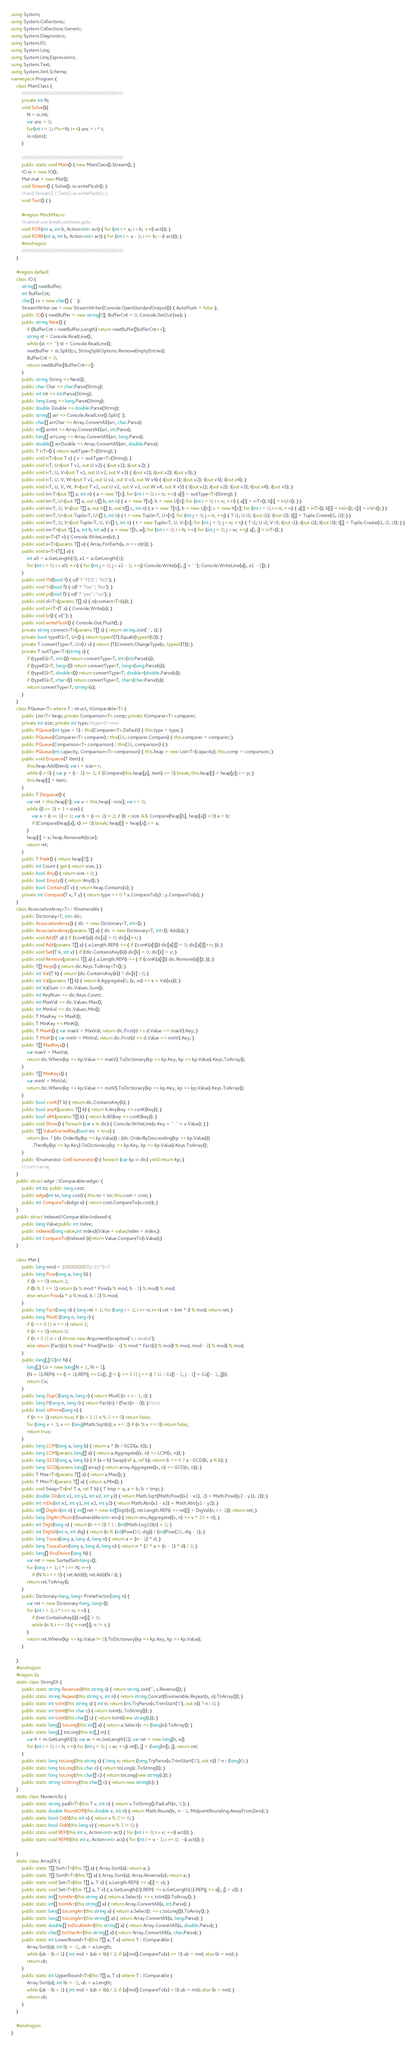Convert code to text. <code><loc_0><loc_0><loc_500><loc_500><_C#_>using System;
using System.Collections;
using System.Collections.Generic;
using System.Diagnostics;
using System.IO;
using System.Linq;
using System.Linq.Expressions;
using System.Text;
using System.Xml.Schema;
namespace Program {
    class MainClass {
        ////////////////////////////////////////////////////////////
        private int N;
        void Solve(){
            N = io.Int;
            var ans = 0;
            for(int i = 1; i*i<=N; i++) ans = i * i;
            io.o(ans);
        } 
                
        ////////////////////////////////////////////////////////////
        public static void Main() { new MainClass().Stream(); }
        IO io = new IO();
        Mat mat = new Mat();
        void Stream() { Solve(); io.writeFlush(); }
        //void Stream() { Test(); io.writeFlush(); }
        void Test() { }

        #region MockMacro
        //cannot use break,continue,goto
        void FOR(int a, int b, Action<int> act) { for (int i = a; i < b; ++i) act(i); }
        void FORR(int a, int b, Action<int> act) { for (int i = a - 1; i >= b; --i) act(i); }        
        #endregion
        ////////////////////////////////////////////////////////////
    }

    #region default
    class IO {
        string[] nextBuffer;
        int BufferCnt;
        char[] cs = new char[] { ' ' };
        StreamWriter sw = new StreamWriter(Console.OpenStandardOutput()) { AutoFlush = false };
        public IO() { nextBuffer = new string[0]; BufferCnt = 0; Console.SetOut(sw); }
        public string Next() {
            if (BufferCnt < nextBuffer.Length) return nextBuffer[BufferCnt++];
            string st = Console.ReadLine();
            while (st == "") st = Console.ReadLine();
            nextBuffer = st.Split(cs, StringSplitOptions.RemoveEmptyEntries);
            BufferCnt = 0;
            return nextBuffer[BufferCnt++];
        }
        public string String => Next();
        public char Char => char.Parse(String);
        public int Int => int.Parse(String);
        public long Long => long.Parse(String);
        public double Double => double.Parse(String);
        public string[] arr => Console.ReadLine().Split(' ');
        public char[] arrChar => Array.ConvertAll(arr, char.Parse);
        public int[] arrInt => Array.ConvertAll(arr, int.Parse);
        public long[] arrLong => Array.ConvertAll(arr, long.Parse);
        public double[] arrDouble => Array.ConvertAll(arr, double.Parse);
        public T i<T>() { return suitType<T>(String); }
        public void i<T>(out T v) { v = suitType<T>(String); }
        public void i<T, U>(out T v1, out U v2) { i(out v1); i(out v2); }
        public void i<T, U, V>(out T v1, out U v2, out V v3) { i(out v1); i(out v2); i(out v3); }
        public void i<T, U, V, W>(out T v1, out U v2, out V v3, out W v4) { i(out v1); i(out v2); i(out v3); i(out v4); }
        public void i<T, U, V, W, X>(out T v1, out U v2, out V v3, out W v4, out X v5) { i(out v1); i(out v2); i(out v3); i(out v4); i(out v5); }
        public void ini<T>(out T[] a, int n) { a = new T[n]; for (int i = 0; i < n; ++i) a[i] = suitType<T>(String); }
        public void ini<T, U>(out T[] a, out U[] b, int n) { a = new T[n]; b = new U[n]; for (int i = 0; i < n; ++i) { a[i] = i<T>(); b[i] = i<U>(); } }
        public void ini<T, U, V>(out T[] a, out U[] b, out V[] c, int n) { a = new T[n]; b = new U[n]; c = new V[n]; for (int i = 0; i < n; ++i) { a[i] = i<T>(); b[i] = i<U>(); c[i] = i<V>(); } }
        public void ini<T, U>(out Tuple<T, U>[] t, int n) { t = new Tuple<T, U>[n]; for (int j = 0; j < n; ++j) { T i1; U i2; i(out i1); i(out i2); t[j] = Tuple.Create(i1, i2); } }
        public void ini<T, U, V>(out Tuple<T, U, V>[] t, int n) { t = new Tuple<T, U, V>[n]; for (int j = 0; j < n; ++j) { T i1; U i2; V i3; i(out i1); i(out i2); i(out i3); t[j] = Tuple.Create(i1, i2, i3); } }
        public void ini<T>(out T[,] a, int h, int w) { a = new T[h, w]; for (int i = 0; i < h; ++i) for (int j = 0; j < w; ++j) a[i, j] = i<T>(); }
        public void o<T>(T v) { Console.WriteLine(v); }
        public void o<T>(params T[] a) { Array.ForEach(a, n => o(n)); }
        public void o<T>(T[,] a) {
            int a0 = a.GetLength(0), a1 = a.GetLength(1);
            for (int i = 0; i < a0; ++i) { for (int j = 0; j < a1 - 1; ++j) Console.Write(a[i, j] + " "); Console.WriteLine(a[i, a1 - 1]); }
        }
        public void YN(bool f) { o(f ? "YES" : "NO"); }
        public void Yn(bool f) { o(f ? "Yes" : "No"); }
        public void yn(bool f) { o(f ? "yes" : "no"); }
        public void ol<T>(params T[] a) { o(connect<T>(a)); }
        public void or<T>(T a) { Console.Write(a); }
        public void br() { o(""); }
        public void writeFlush() { Console.Out.Flush(); }
        private string connect<T>(params T[] s) { return string.Join(" ", s); }
        private bool typeEQ<T, U>() { return typeof(T).Equals(typeof(U)); }
        private T convertType<T, U>(U v) { return (T)Convert.ChangeType(v, typeof(T)); }
        private T suitType<T>(string s) {
            if (typeEQ<T, int>()) return convertType<T, int>(int.Parse(s));
            if (typeEQ<T, long>()) return convertType<T, long>(long.Parse(s));
            if (typeEQ<T, double>()) return convertType<T, double>(double.Parse(s));
            if (typeEQ<T, char>()) return convertType<T, char>(char.Parse(s));
            return convertType<T, string>(s);
        }
    }
    class PQueue<T> where T : struct, IComparable<T> {
        public List<T> heap; private Comparison<T> comp; private IComparer<T> comparer;
        private int size; private int type;//type=0->min
        public PQueue(int type = 0) : this(Comparer<T>.Default) { this.type = type; }
        public PQueue(IComparer<T> comparer) : this(16, comparer.Compare) { this.comparer = comparer; }
        public PQueue(Comparison<T> comparison) : this(16, comparison) { }
        public PQueue(int capacity, Comparison<T> comparison) { this.heap = new List<T>(capacity); this.comp = comparison; }
        public void Enqueue(T item) {
            this.heap.Add(item); var i = size++;
            while (i > 0) { var p = (i - 1) >> 1; if (Compare(this.heap[p], item) <= 0) break; this.heap[i] = heap[p]; i = p; }
            this.heap[i] = item;
        }
        public T Dequeue() {
            var ret = this.heap[0]; var x = this.heap[--size]; var i = 0;
            while ((i << 1) + 1 < size) {
                var a = (i << 1) + 1; var b = (i << 1) + 2; if (b < size && Compare(heap[b], heap[a]) < 0) a = b;
                if (Compare(heap[a], x) >= 0) break; heap[i] = heap[a]; i = a;
            }
            heap[i] = x; heap.RemoveAt(size);
            return ret;
        }
        public T Peek() { return heap[0]; }
        public int Count { get { return size; } }
        public bool Any() { return size > 0; }
        public bool Empty() { return !Any(); }
        public bool Contains(T v) { return heap.Contains(v); }
        private int Compare(T x, T y) { return type == 0 ? x.CompareTo(y) : y.CompareTo(x); }
    }
    class AssociativeArray<T> : IEnumerable {
        public Dictionary<T, int> dic;
        public AssociativeArray() { dic = new Dictionary<T, int>(); }
        public AssociativeArray(params T[] a) { dic = new Dictionary<T, int>(); Add(a); }
        public void Add(T a) { if (!conK(a)) dic[a] = 0; dic[a]++; }
        public void Add(params T[] a) { a.Length.REP(i => { if (!conK(a[i])) dic[a[i]] = 0; dic[a[i]]++; }); }
        public void Set(T k, int v) { if (!dic.ContainsKey(k)) dic[k] = 0; dic[k] = v; }
        public void Remove(params T[] a) { a.Length.REP(i => { if (conK(a[i])) dic.Remove(a[i]); }); }
        public T[] Keys() { return dic.Keys.ToArray<T>(); }
        public int Val(T k) { return (dic.ContainsKey(k)) ? dic[k] : 0; }
        public int Val(params T[] k) { return k.Aggregate(0, (x, xs) => x + Val(xs)); }
        public int ValSum => dic.Values.Sum();
        public int KeyNum => dic.Keys.Count;
        public int MaxVal => dic.Values.Max();
        public int MinVal => dic.Values.Min();
        public T MaxKey => MaxK();
        public T MinKey => MinK();
        public T MaxK() { var maxV = MaxVal; return dic.First(d => d.Value == maxV).Key; }
        public T MinK() { var minV = MinVal; return dic.First(d => d.Value == minV).Key; }
        public T[] MaxKeys() {
            var maxV = MaxVal;
            return dic.Where(kp => kp.Value == maxV).ToDictionary(kp => kp.Key, kp => kp.Value).Keys.ToArray();
        }
        public T[] MinKeys() {
            var minV = MinVal;
            return dic.Where(kp => kp.Value == minV).ToDictionary(kp => kp.Key, kp => kp.Value).Keys.ToArray();
        }
        public bool conK(T k) { return dic.ContainsKey(k); }
        public bool anyK(params T[] k) { return k.Any(key => conK(key)); }
        public bool allK(params T[] k) { return k.All(key => conK(key)); }
        public void Show() { foreach (var v in dic) { Console.WriteLine(v.Key + " : " + v.Value); } }
        public T[] ValueSortedKey(bool inc = true) {
            return (inc ? (dic.OrderBy(kp => kp.Value)) : (dic.OrderByDescending(kp => kp.Value)))
                .ThenBy(kp => kp.Key).ToDictionary(kp => kp.Key, kp => kp.Value).Keys.ToArray();
        }
        public IEnumerator GetEnumerator() { foreach (var kp in dic) yield return kp; }
        //:sort->array
    }
    public struct edge : IComparable<edge> {
        public int to; public long cost;
        public edge(int to, long cost) { this.to = to; this.cost = cost; }
        public int CompareTo(edge e) { return cost.CompareTo(e.cost); }
    }
    public struct Indexed:IComparable<Indexed>{
        public long Value;public int Index;
        public Indexed(long value,int index){Value = value;Index = index;}
        public int CompareTo(Indexed i){return Value.CompareTo(i.Value);}
    }
    
    class Mat {
        public long mod = 1000000007;//10^9+7
        public long Pow(long a, long b) {
            if (b == 0) return 1;
            if (b % 2 == 1) return (a % mod * Pow(a % mod, b - 1) % mod) % mod;
            else return Pow(a * a % mod, b / 2) % mod;
        }
        public long Fact(long n) { long ret = 1; for (long i = 1; i <= n; i++) ret = (ret * i) % mod; return ret; }
        public long ModC(long n, long r) {
            if (r == 0 || n == r) return 1;
            if (n == 0) return 0;
            if (n < 0 || n < r) throw new ArgumentException("n,r invalid");
            else return (Fact(n) % mod * Pow((Fact(n - r) % mod * Fact(r) % mod) % mod, mod - 2) % mod) % mod;
        }
        public long[,] C(int N) {
            long[,] Co = new long[N + 1, N + 1];
            (N + 1).REP(i => (i + 1).REP(j => Co[i, j] = (j == 0 || j == i) ? 1L : Co[i - 1, j - 1] + Co[i - 1, j]));
            return Co;
        }
        public long DupC(long n, long r) { return ModC(n + r - 1, r); }
        public long P(long n, long r) { return Fact(n) / (Fact(n - r)); }//test
        public bool isPrime(long n) {
            if (n == 2) return true; if (n < 2 || n % 2 == 0) return false;
            for (long v = 3; v <= (long)Math.Sqrt(n); v += 2) if (n % v == 0) return false;
            return true;
        }
        public long LCM(long a, long b) { return a * (b / GCD(a, b)); }
        public long LCM(params long[] a) { return a.Aggregate((v, n) => LCM(v, n)); }
        public long GCD(long a, long b) { if (a < b) Swap(ref a, ref b); return b == 0 ? a : GCD(b, a % b); }
        public long GCD(params long[] array) { return array.Aggregate((v, n) => GCD(v, n)); }
        public T Max<T>(params T[] a) { return a.Max(); }
        public T Min<T>(params T[] a) { return a.Min(); }
        public void Swap<T>(ref T a, ref T b) { T tmp = a; a = b; b = tmp; }
        public double Dis(int x1, int y1, int x2, int y2) { return Math.Sqrt(Math.Pow((x2 - x1), 2) + Math.Pow((y2 - y1), 2)); }
        public int mDis(int x1, int y1, int x2, int y2) { return Math.Abs(x1 - x2) + Math.Abs(y1 - y2); }
        public int[] DigArr(int n) { int[] ret = new int[Digit(n)]; ret.Length.REP(i => ret[i] = DigVal(n, i + 1)); return ret; }
        public long DigArr2Num(IEnumerable<int> enu) { return enu.Aggregate((v, n) => v * 10 + n); }
        public int Digit(long n) { return (n == 0) ? 1 : (int)Math.Log10(n) + 1; }
        public int DigVal(int n, int dig) { return (n % (int)Pow(10, dig)) / (int)Pow(10, dig - 1); }
        public long Tousa(long a, long d, long n) { return a + (n - 1) * d; }
        public long TousaSum(long a, long d, long n) { return n * (2 * a + (n - 1) * d) / 2; }
        public long[] EnuDivsor(long N) {
            var ret = new SortedSet<long>();
            for (long i = 1; i * i <= N; i++)
                if (N % i == 0) { ret.Add(i); ret.Add(N / i); }
            return ret.ToArray();
        }
        public Dictionary<long, long> PrimeFactor(long n) {
            var ret = new Dictionary<long, long>();
            for (int i = 2; i * i <= n; ++i) {
                if (!ret.ContainsKey(i)) ret[i] = 0;
                while (n % i == 0) { ++ret[i]; n /= i; }
            }
            return ret.Where(kp => kp.Value != 0).ToDictionary(kp => kp.Key, kp => kp.Value);
        }
        
    }
    #endregion   
    #region Ex
    static class StringEX {
        public static string Reversed(this string s) { return string.Join("", s.Reverse()); }
        public static string Repeat(this string s, int n) { return string.Concat(Enumerable.Repeat(s, n).ToArray()); }
        public static int toInt(this string s) { int n; return (int.TryParse(s.TrimStart('0'), out n)) ? n : 0; }
        public static int toInt(this char c) { return toInt(c.ToString()); }
        public static int toInt(this char[] c) { return toInt(new string(c)); }
        public static long[] toLong(this int[] a) { return a.Select(v => (long)v).ToArray(); }
        public static long[,] toLong(this int[,] m) {
            var h = m.GetLength(0); var w = m.GetLength(1); var ret = new long[h, w];
            for (int i = 0; i < h; ++i) for (int j = 0; j < w; ++j) ret[i, j] = (long)m[i, j]; return ret;
        }
        public static long toLong(this string s) { long n; return (long.TryParse(s.TrimStart('0'), out n)) ? n : (long)0; }
        public static long toLong(this char c) { return toLong(c.ToString()); }
        public static long toLong(this char[] c) { return toLong(new string(c)); }
        public static string toString(this char[] c) { return new string(c); }
    }
    static class NumericEx {
        public static string pad0<T>(this T v, int n) { return v.ToString().PadLeft(n, '0'); }
        public static double RoundOff(this double v, int n) { return Math.Round(v, n - 1, MidpointRounding.AwayFromZero); }
        public static bool Odd(this int v) { return v % 2 != 0; }
        public static bool Odd(this long v) { return v % 2 != 0; }
        public static void REP(this int v, Action<int> act) { for (int i = 0; i < v; ++i) act(i); }
        public static void REPR(this int v, Action<int> act) { for (int i = v - 1; i >= 0; --i) act(i); }        
        
    }
    static class ArrayEX {
        public static T[] Sort<T>(this T[] a) { Array.Sort(a); return a; }
        public static T[] SortR<T>(this T[] a) { Array.Sort(a); Array.Reverse(a); return a; }
        public static void Set<T>(this T[] a, T v) { a.Length.REP(i => a[i] = v); }
        public static void Set<T>(this T[,] a, T v) { a.GetLength(0).REP(i => a.GetLength(1).REP(j => a[i, j] = v)); }
        public static int[] toIntArr(this string a) { return a.Select(c => c.toInt()).ToArray(); }
        public static int[] toIntArr(this string[] a) { return Array.ConvertAll(a, int.Parse); }
        public static long[] toLongArr(this string a) { return a.Select(c => c.toLong()).ToArray(); }
        public static long[] toLongArr(this string[] a) { return Array.ConvertAll(a, long.Parse); }
        public static double[] toDoubleArr(this string[] a) { return Array.ConvertAll(a, double.Parse); }
        public static char[] toCharArr(this string[] a) { return Array.ConvertAll(a, char.Parse); }
        public static int LowerBound<T>(this T[] a, T x) where T : IComparable {
            Array.Sort(a); int lb = -1, ub = a.Length;
            while (ub - lb > 1) { int mid = (ub + lb) / 2; if (a[mid].CompareTo(x) >= 0) ub = mid; else lb = mid; }
            return ub;
        }
        public static int UpperBound<T>(this T[] a, T x) where T : IComparable {
            Array.Sort(a); int lb = -1, ub = a.Length;
            while (ub - lb > 1) { int mid = (ub + lb) / 2; if (a[mid].CompareTo(x) > 0) ub = mid; else lb = mid; }
            return ub;
        }
    }

    #endregion
}</code> 